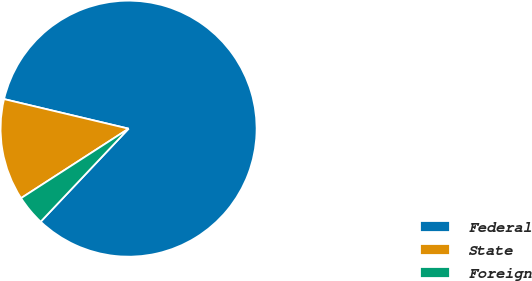Convert chart. <chart><loc_0><loc_0><loc_500><loc_500><pie_chart><fcel>Federal<fcel>State<fcel>Foreign<nl><fcel>83.34%<fcel>12.84%<fcel>3.82%<nl></chart> 